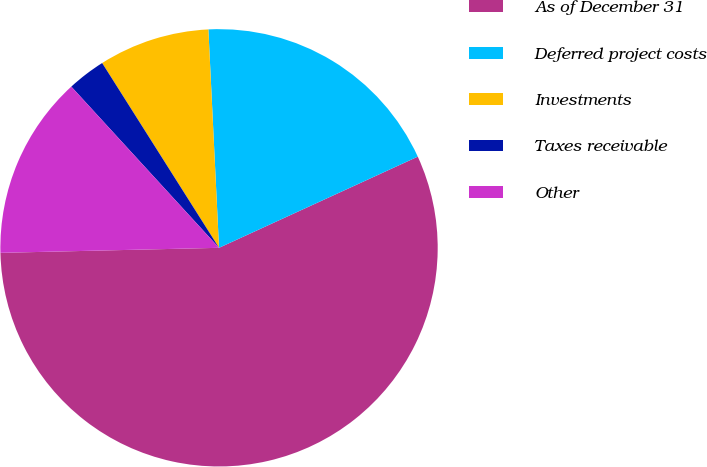<chart> <loc_0><loc_0><loc_500><loc_500><pie_chart><fcel>As of December 31<fcel>Deferred project costs<fcel>Investments<fcel>Taxes receivable<fcel>Other<nl><fcel>56.48%<fcel>18.93%<fcel>8.2%<fcel>2.83%<fcel>13.56%<nl></chart> 